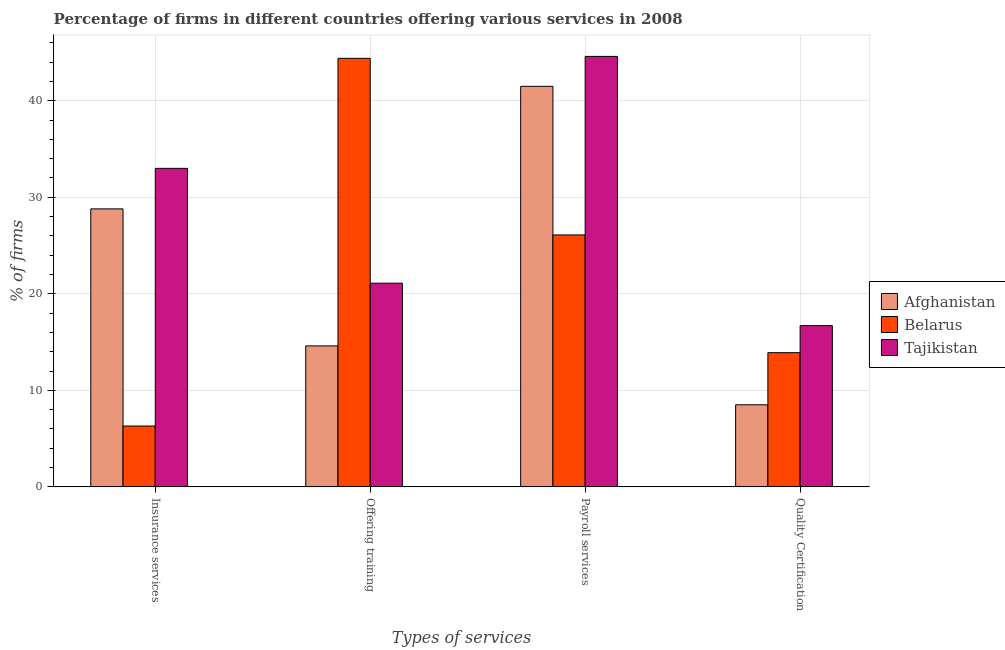How many groups of bars are there?
Provide a short and direct response. 4. How many bars are there on the 4th tick from the left?
Your answer should be very brief. 3. How many bars are there on the 3rd tick from the right?
Ensure brevity in your answer.  3. What is the label of the 3rd group of bars from the left?
Offer a terse response. Payroll services. Across all countries, what is the maximum percentage of firms offering payroll services?
Your answer should be compact. 44.6. Across all countries, what is the minimum percentage of firms offering insurance services?
Offer a terse response. 6.3. In which country was the percentage of firms offering payroll services maximum?
Give a very brief answer. Tajikistan. In which country was the percentage of firms offering insurance services minimum?
Make the answer very short. Belarus. What is the total percentage of firms offering payroll services in the graph?
Your answer should be very brief. 112.2. What is the difference between the percentage of firms offering quality certification in Belarus and that in Tajikistan?
Your response must be concise. -2.8. What is the difference between the percentage of firms offering payroll services in Tajikistan and the percentage of firms offering quality certification in Belarus?
Provide a short and direct response. 30.7. What is the average percentage of firms offering quality certification per country?
Offer a very short reply. 13.03. What is the difference between the percentage of firms offering training and percentage of firms offering insurance services in Afghanistan?
Your answer should be compact. -14.2. What is the ratio of the percentage of firms offering insurance services in Belarus to that in Tajikistan?
Offer a very short reply. 0.19. Is the difference between the percentage of firms offering payroll services in Belarus and Tajikistan greater than the difference between the percentage of firms offering training in Belarus and Tajikistan?
Your answer should be very brief. No. What is the difference between the highest and the second highest percentage of firms offering quality certification?
Your answer should be very brief. 2.8. What is the difference between the highest and the lowest percentage of firms offering insurance services?
Your response must be concise. 26.7. In how many countries, is the percentage of firms offering training greater than the average percentage of firms offering training taken over all countries?
Give a very brief answer. 1. Is it the case that in every country, the sum of the percentage of firms offering quality certification and percentage of firms offering training is greater than the sum of percentage of firms offering insurance services and percentage of firms offering payroll services?
Offer a terse response. No. What does the 1st bar from the left in Payroll services represents?
Your answer should be compact. Afghanistan. What does the 3rd bar from the right in Payroll services represents?
Give a very brief answer. Afghanistan. Is it the case that in every country, the sum of the percentage of firms offering insurance services and percentage of firms offering training is greater than the percentage of firms offering payroll services?
Your answer should be very brief. Yes. Are all the bars in the graph horizontal?
Offer a terse response. No. How many countries are there in the graph?
Offer a terse response. 3. What is the difference between two consecutive major ticks on the Y-axis?
Provide a succinct answer. 10. Are the values on the major ticks of Y-axis written in scientific E-notation?
Your response must be concise. No. Does the graph contain any zero values?
Offer a very short reply. No. Where does the legend appear in the graph?
Your response must be concise. Center right. How are the legend labels stacked?
Keep it short and to the point. Vertical. What is the title of the graph?
Provide a succinct answer. Percentage of firms in different countries offering various services in 2008. What is the label or title of the X-axis?
Keep it short and to the point. Types of services. What is the label or title of the Y-axis?
Give a very brief answer. % of firms. What is the % of firms in Afghanistan in Insurance services?
Keep it short and to the point. 28.8. What is the % of firms of Belarus in Offering training?
Ensure brevity in your answer.  44.4. What is the % of firms of Tajikistan in Offering training?
Provide a short and direct response. 21.1. What is the % of firms in Afghanistan in Payroll services?
Ensure brevity in your answer.  41.5. What is the % of firms in Belarus in Payroll services?
Your answer should be compact. 26.1. What is the % of firms in Tajikistan in Payroll services?
Offer a very short reply. 44.6. What is the % of firms in Afghanistan in Quality Certification?
Make the answer very short. 8.5. What is the % of firms in Tajikistan in Quality Certification?
Keep it short and to the point. 16.7. Across all Types of services, what is the maximum % of firms in Afghanistan?
Provide a succinct answer. 41.5. Across all Types of services, what is the maximum % of firms in Belarus?
Offer a very short reply. 44.4. Across all Types of services, what is the maximum % of firms in Tajikistan?
Provide a succinct answer. 44.6. Across all Types of services, what is the minimum % of firms in Afghanistan?
Your response must be concise. 8.5. Across all Types of services, what is the minimum % of firms in Tajikistan?
Give a very brief answer. 16.7. What is the total % of firms of Afghanistan in the graph?
Your response must be concise. 93.4. What is the total % of firms of Belarus in the graph?
Keep it short and to the point. 90.7. What is the total % of firms in Tajikistan in the graph?
Offer a terse response. 115.4. What is the difference between the % of firms in Belarus in Insurance services and that in Offering training?
Provide a short and direct response. -38.1. What is the difference between the % of firms in Tajikistan in Insurance services and that in Offering training?
Your answer should be compact. 11.9. What is the difference between the % of firms in Afghanistan in Insurance services and that in Payroll services?
Keep it short and to the point. -12.7. What is the difference between the % of firms of Belarus in Insurance services and that in Payroll services?
Ensure brevity in your answer.  -19.8. What is the difference between the % of firms in Tajikistan in Insurance services and that in Payroll services?
Ensure brevity in your answer.  -11.6. What is the difference between the % of firms of Afghanistan in Insurance services and that in Quality Certification?
Ensure brevity in your answer.  20.3. What is the difference between the % of firms in Tajikistan in Insurance services and that in Quality Certification?
Your response must be concise. 16.3. What is the difference between the % of firms of Afghanistan in Offering training and that in Payroll services?
Your response must be concise. -26.9. What is the difference between the % of firms of Tajikistan in Offering training and that in Payroll services?
Offer a terse response. -23.5. What is the difference between the % of firms in Belarus in Offering training and that in Quality Certification?
Provide a succinct answer. 30.5. What is the difference between the % of firms of Afghanistan in Payroll services and that in Quality Certification?
Provide a succinct answer. 33. What is the difference between the % of firms of Belarus in Payroll services and that in Quality Certification?
Make the answer very short. 12.2. What is the difference between the % of firms in Tajikistan in Payroll services and that in Quality Certification?
Give a very brief answer. 27.9. What is the difference between the % of firms in Afghanistan in Insurance services and the % of firms in Belarus in Offering training?
Provide a short and direct response. -15.6. What is the difference between the % of firms of Belarus in Insurance services and the % of firms of Tajikistan in Offering training?
Your answer should be very brief. -14.8. What is the difference between the % of firms of Afghanistan in Insurance services and the % of firms of Belarus in Payroll services?
Offer a very short reply. 2.7. What is the difference between the % of firms in Afghanistan in Insurance services and the % of firms in Tajikistan in Payroll services?
Your answer should be very brief. -15.8. What is the difference between the % of firms in Belarus in Insurance services and the % of firms in Tajikistan in Payroll services?
Your answer should be very brief. -38.3. What is the difference between the % of firms in Afghanistan in Insurance services and the % of firms in Belarus in Quality Certification?
Your response must be concise. 14.9. What is the difference between the % of firms of Belarus in Insurance services and the % of firms of Tajikistan in Quality Certification?
Your answer should be very brief. -10.4. What is the difference between the % of firms in Afghanistan in Offering training and the % of firms in Tajikistan in Payroll services?
Offer a very short reply. -30. What is the difference between the % of firms in Belarus in Offering training and the % of firms in Tajikistan in Payroll services?
Make the answer very short. -0.2. What is the difference between the % of firms of Afghanistan in Offering training and the % of firms of Tajikistan in Quality Certification?
Your response must be concise. -2.1. What is the difference between the % of firms of Belarus in Offering training and the % of firms of Tajikistan in Quality Certification?
Offer a terse response. 27.7. What is the difference between the % of firms in Afghanistan in Payroll services and the % of firms in Belarus in Quality Certification?
Ensure brevity in your answer.  27.6. What is the difference between the % of firms in Afghanistan in Payroll services and the % of firms in Tajikistan in Quality Certification?
Provide a succinct answer. 24.8. What is the difference between the % of firms of Belarus in Payroll services and the % of firms of Tajikistan in Quality Certification?
Keep it short and to the point. 9.4. What is the average % of firms in Afghanistan per Types of services?
Provide a short and direct response. 23.35. What is the average % of firms in Belarus per Types of services?
Give a very brief answer. 22.68. What is the average % of firms in Tajikistan per Types of services?
Keep it short and to the point. 28.85. What is the difference between the % of firms of Afghanistan and % of firms of Belarus in Insurance services?
Keep it short and to the point. 22.5. What is the difference between the % of firms of Afghanistan and % of firms of Tajikistan in Insurance services?
Offer a very short reply. -4.2. What is the difference between the % of firms of Belarus and % of firms of Tajikistan in Insurance services?
Give a very brief answer. -26.7. What is the difference between the % of firms of Afghanistan and % of firms of Belarus in Offering training?
Offer a very short reply. -29.8. What is the difference between the % of firms in Afghanistan and % of firms in Tajikistan in Offering training?
Ensure brevity in your answer.  -6.5. What is the difference between the % of firms of Belarus and % of firms of Tajikistan in Offering training?
Keep it short and to the point. 23.3. What is the difference between the % of firms of Belarus and % of firms of Tajikistan in Payroll services?
Offer a terse response. -18.5. What is the ratio of the % of firms of Afghanistan in Insurance services to that in Offering training?
Give a very brief answer. 1.97. What is the ratio of the % of firms in Belarus in Insurance services to that in Offering training?
Keep it short and to the point. 0.14. What is the ratio of the % of firms in Tajikistan in Insurance services to that in Offering training?
Keep it short and to the point. 1.56. What is the ratio of the % of firms of Afghanistan in Insurance services to that in Payroll services?
Offer a very short reply. 0.69. What is the ratio of the % of firms of Belarus in Insurance services to that in Payroll services?
Your answer should be very brief. 0.24. What is the ratio of the % of firms in Tajikistan in Insurance services to that in Payroll services?
Your answer should be very brief. 0.74. What is the ratio of the % of firms in Afghanistan in Insurance services to that in Quality Certification?
Provide a short and direct response. 3.39. What is the ratio of the % of firms of Belarus in Insurance services to that in Quality Certification?
Your answer should be compact. 0.45. What is the ratio of the % of firms in Tajikistan in Insurance services to that in Quality Certification?
Offer a terse response. 1.98. What is the ratio of the % of firms in Afghanistan in Offering training to that in Payroll services?
Provide a short and direct response. 0.35. What is the ratio of the % of firms in Belarus in Offering training to that in Payroll services?
Keep it short and to the point. 1.7. What is the ratio of the % of firms of Tajikistan in Offering training to that in Payroll services?
Provide a short and direct response. 0.47. What is the ratio of the % of firms of Afghanistan in Offering training to that in Quality Certification?
Provide a short and direct response. 1.72. What is the ratio of the % of firms in Belarus in Offering training to that in Quality Certification?
Make the answer very short. 3.19. What is the ratio of the % of firms in Tajikistan in Offering training to that in Quality Certification?
Provide a short and direct response. 1.26. What is the ratio of the % of firms in Afghanistan in Payroll services to that in Quality Certification?
Provide a short and direct response. 4.88. What is the ratio of the % of firms of Belarus in Payroll services to that in Quality Certification?
Provide a succinct answer. 1.88. What is the ratio of the % of firms of Tajikistan in Payroll services to that in Quality Certification?
Provide a succinct answer. 2.67. What is the difference between the highest and the second highest % of firms in Afghanistan?
Provide a short and direct response. 12.7. What is the difference between the highest and the lowest % of firms in Belarus?
Provide a succinct answer. 38.1. What is the difference between the highest and the lowest % of firms in Tajikistan?
Offer a very short reply. 27.9. 